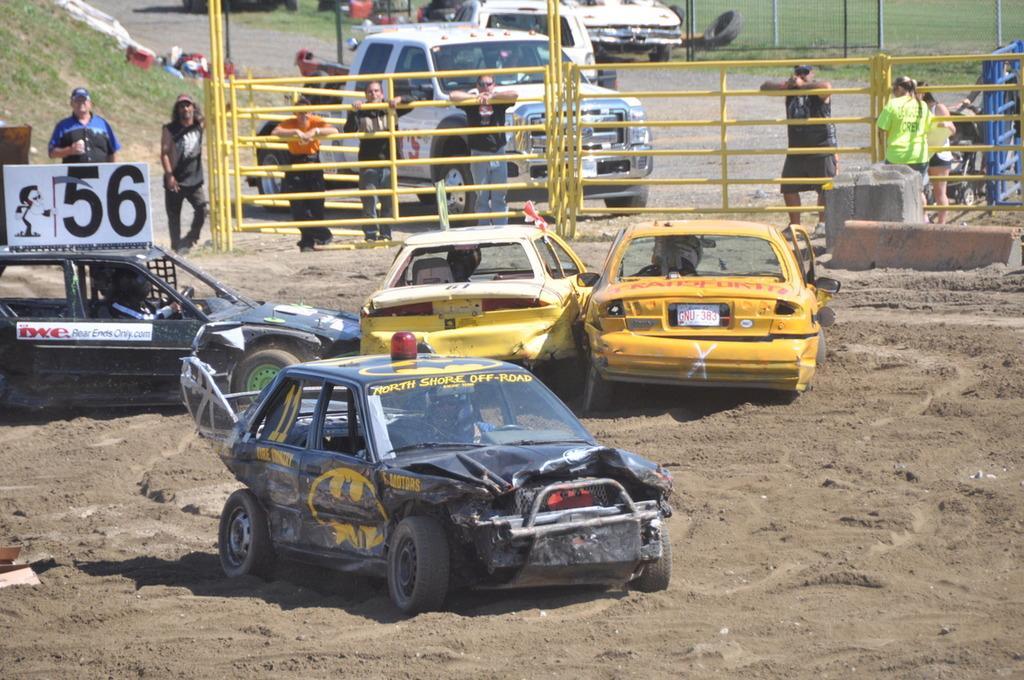Could you give a brief overview of what you see in this image? In this image we can see many cars on the ground. In the background we can see fencing, persons, cars, grass, poles and road. 